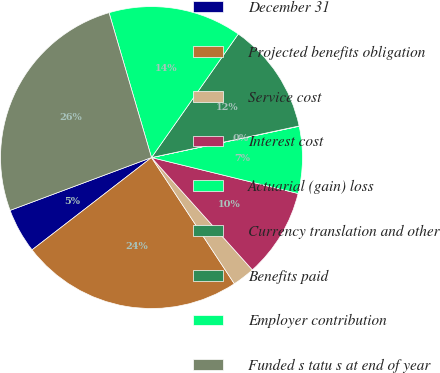<chart> <loc_0><loc_0><loc_500><loc_500><pie_chart><fcel>December 31<fcel>Projected benefits obligation<fcel>Service cost<fcel>Interest cost<fcel>Actuarial (gain) loss<fcel>Currency translation and other<fcel>Benefits paid<fcel>Employer contribution<fcel>Funded s tatu s at end of year<nl><fcel>4.78%<fcel>23.77%<fcel>2.4%<fcel>9.53%<fcel>7.15%<fcel>0.03%<fcel>11.9%<fcel>14.28%<fcel>26.15%<nl></chart> 